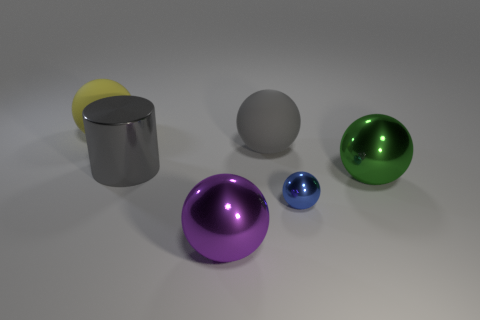There is a ball that is the same color as the metallic cylinder; what material is it?
Provide a short and direct response. Rubber. What size is the thing that is the same color as the shiny cylinder?
Ensure brevity in your answer.  Large. Is there a cylinder that has the same size as the blue sphere?
Provide a short and direct response. No. Does the big rubber thing on the left side of the gray metal thing have the same color as the big metallic thing that is right of the purple metallic thing?
Offer a very short reply. No. Is there a metallic cube that has the same color as the large cylinder?
Your answer should be compact. No. How many other objects are the same shape as the big purple metallic object?
Make the answer very short. 4. There is a gray object that is left of the purple thing; what is its shape?
Give a very brief answer. Cylinder. There is a blue object; is its shape the same as the shiny thing on the right side of the small blue ball?
Your answer should be very brief. Yes. There is a metal thing that is left of the small blue metallic sphere and behind the purple shiny thing; what size is it?
Your answer should be compact. Large. There is a big metallic object that is both behind the small metallic thing and left of the gray matte ball; what is its color?
Offer a very short reply. Gray. 